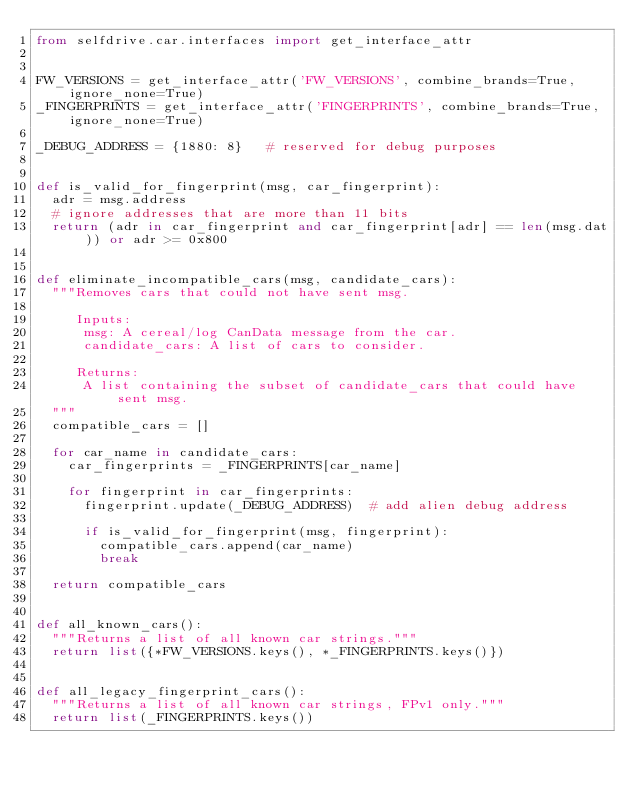Convert code to text. <code><loc_0><loc_0><loc_500><loc_500><_Python_>from selfdrive.car.interfaces import get_interface_attr


FW_VERSIONS = get_interface_attr('FW_VERSIONS', combine_brands=True, ignore_none=True)
_FINGERPRINTS = get_interface_attr('FINGERPRINTS', combine_brands=True, ignore_none=True)

_DEBUG_ADDRESS = {1880: 8}   # reserved for debug purposes


def is_valid_for_fingerprint(msg, car_fingerprint):
  adr = msg.address
  # ignore addresses that are more than 11 bits
  return (adr in car_fingerprint and car_fingerprint[adr] == len(msg.dat)) or adr >= 0x800


def eliminate_incompatible_cars(msg, candidate_cars):
  """Removes cars that could not have sent msg.

     Inputs:
      msg: A cereal/log CanData message from the car.
      candidate_cars: A list of cars to consider.

     Returns:
      A list containing the subset of candidate_cars that could have sent msg.
  """
  compatible_cars = []

  for car_name in candidate_cars:
    car_fingerprints = _FINGERPRINTS[car_name]

    for fingerprint in car_fingerprints:
      fingerprint.update(_DEBUG_ADDRESS)  # add alien debug address

      if is_valid_for_fingerprint(msg, fingerprint):
        compatible_cars.append(car_name)
        break

  return compatible_cars


def all_known_cars():
  """Returns a list of all known car strings."""
  return list({*FW_VERSIONS.keys(), *_FINGERPRINTS.keys()})


def all_legacy_fingerprint_cars():
  """Returns a list of all known car strings, FPv1 only."""
  return list(_FINGERPRINTS.keys())
</code> 